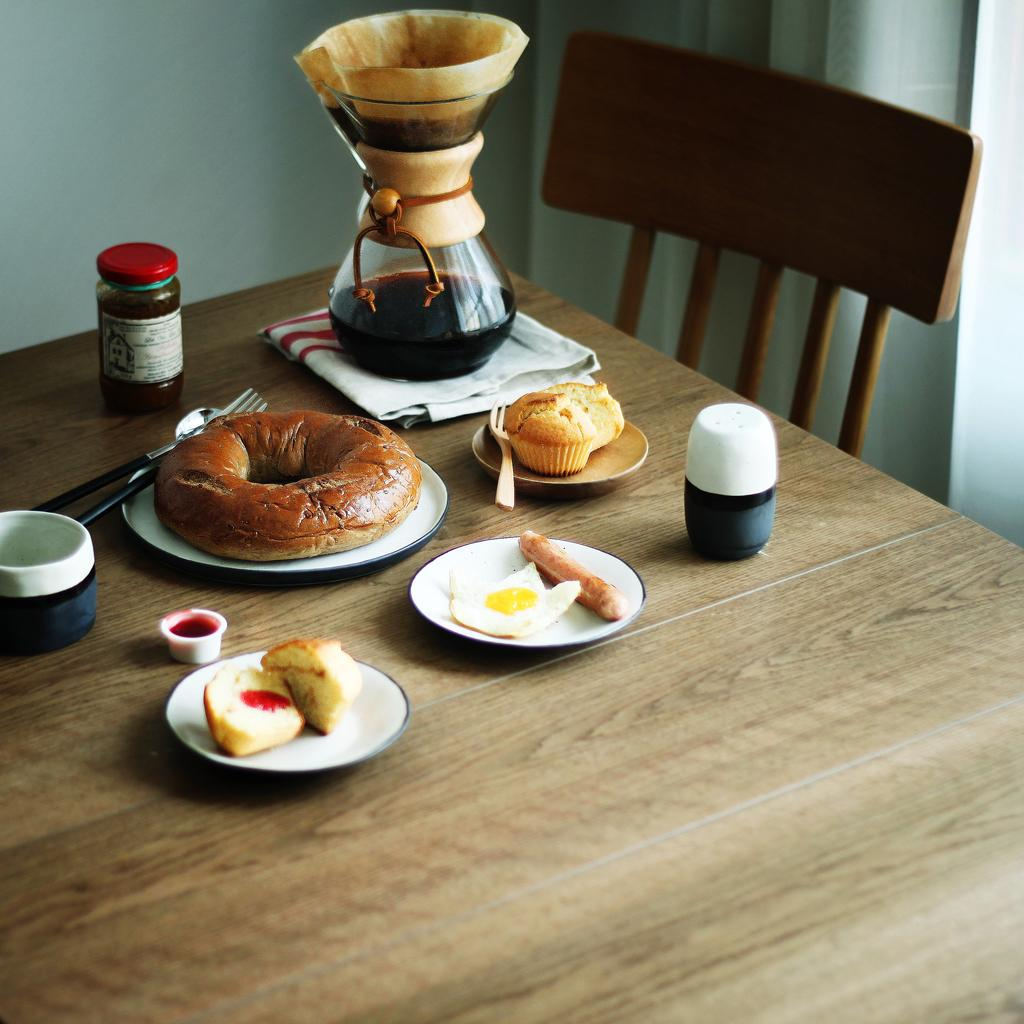What type of container is visible in the image? There is a bottle in the image. What utensil can be seen in the image? There is a spoon in the image. What other utensil is present in the image? There is a fork in the image. What type of food is visible in the image? There is a doughnut and a cake in the image. What is on the plate in the image? There is food on a plate in the image. What type of food item is in a separate container? There is a jam bottle in the image. What is placed on a cloth in the image? There is a vessel on a cloth in the image. What type of furniture is present in the image? There is a chair in the image. How many bears are sitting on the chair in the image? There are no bears present in the image; only the chair is visible. What type of bubble is floating around the doughnut in the image? There are no bubbles present in the image; it only features a doughnut and other food items. 